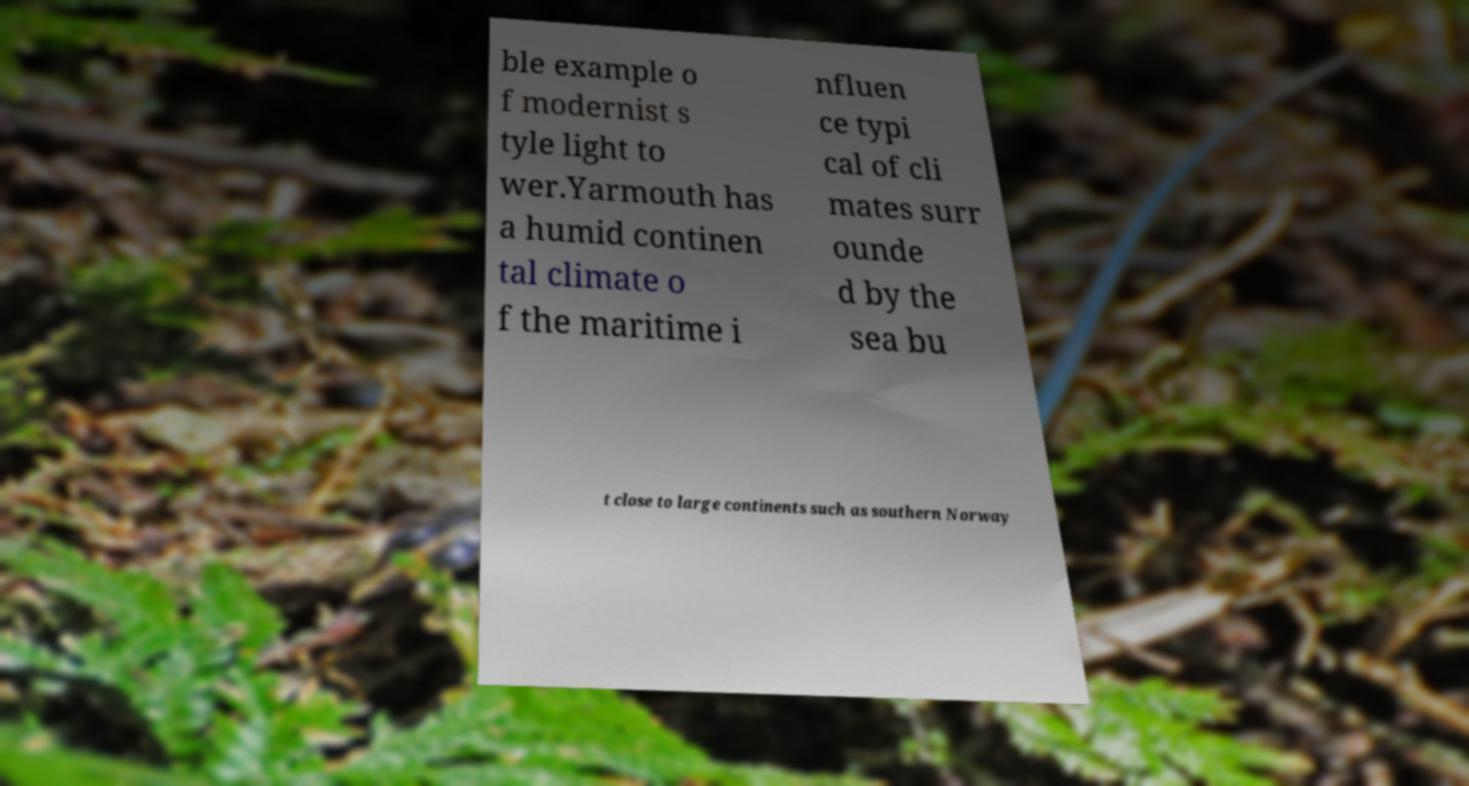Please read and relay the text visible in this image. What does it say? ble example o f modernist s tyle light to wer.Yarmouth has a humid continen tal climate o f the maritime i nfluen ce typi cal of cli mates surr ounde d by the sea bu t close to large continents such as southern Norway 